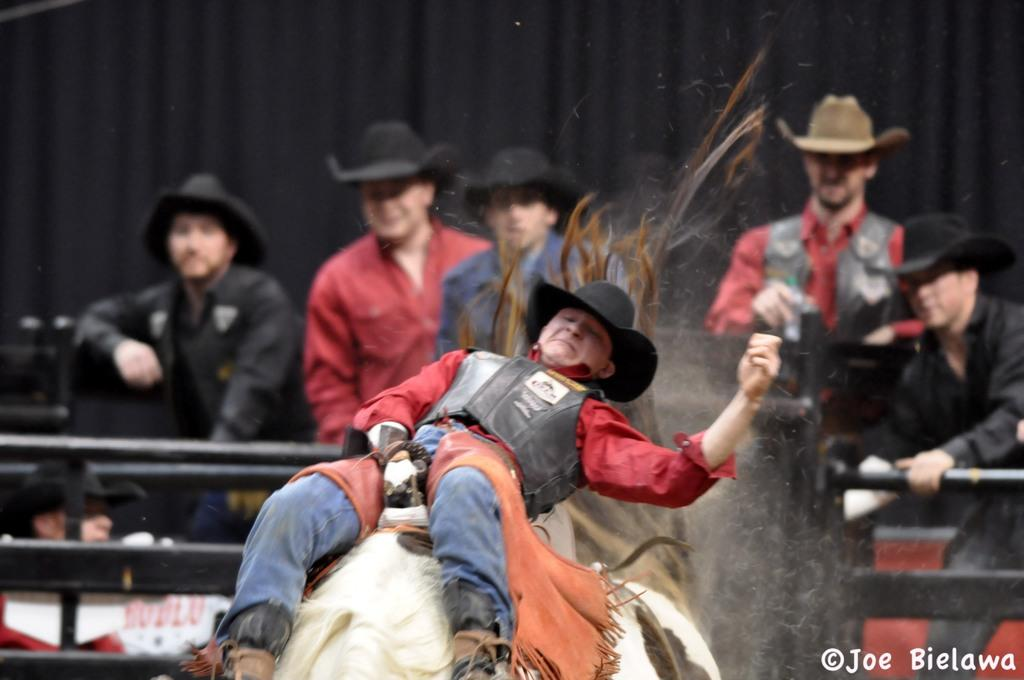What is the main subject of the image? The main subject of the image is a person riding a bulakart. Are there any other people in the image? Yes, there are other persons visible in the image, possibly standing or sitting behind the person on the bulakart. What is the voice of the mom saying in the image? There is no mention of a mom or any voice in the image; it only shows a person riding a bulakart and possibly other people nearby. 